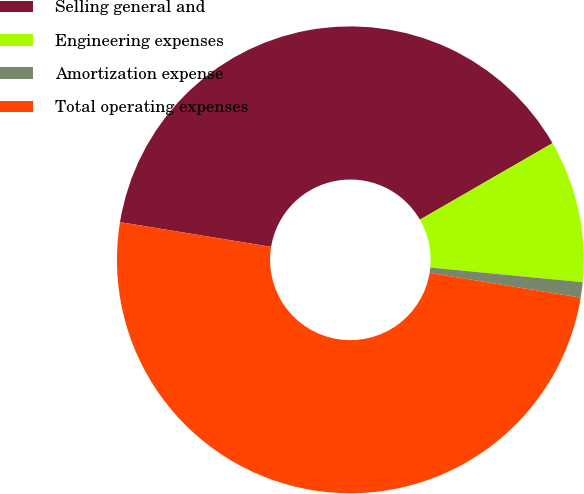Convert chart. <chart><loc_0><loc_0><loc_500><loc_500><pie_chart><fcel>Selling general and<fcel>Engineering expenses<fcel>Amortization expense<fcel>Total operating expenses<nl><fcel>39.09%<fcel>9.86%<fcel>1.06%<fcel>50.0%<nl></chart> 